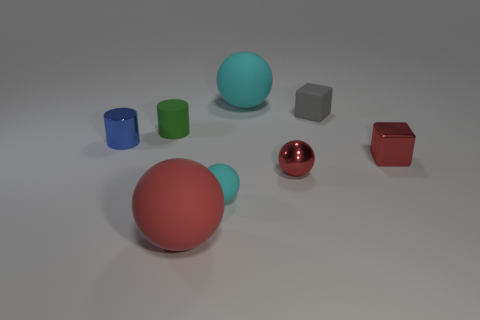Do the gray rubber object and the matte object that is to the left of the large red ball have the same shape?
Keep it short and to the point. No. How many small things are blue metal things or red blocks?
Make the answer very short. 2. Is there a cyan matte sphere that has the same size as the red metal ball?
Offer a terse response. Yes. The big rubber thing left of the cyan object in front of the blue metallic cylinder that is left of the small cyan sphere is what color?
Provide a short and direct response. Red. Are the tiny blue cylinder and the large sphere behind the large red ball made of the same material?
Keep it short and to the point. No. There is another metal object that is the same shape as the green thing; what is its size?
Offer a very short reply. Small. Is the number of rubber cylinders that are left of the tiny blue shiny cylinder the same as the number of tiny metal objects that are on the left side of the big red sphere?
Give a very brief answer. No. How many other objects are the same material as the blue object?
Give a very brief answer. 2. Are there the same number of red cubes that are on the left side of the green cylinder and cyan matte spheres?
Your answer should be very brief. No. Does the gray object have the same size as the cyan matte ball that is behind the tiny blue thing?
Give a very brief answer. No. 